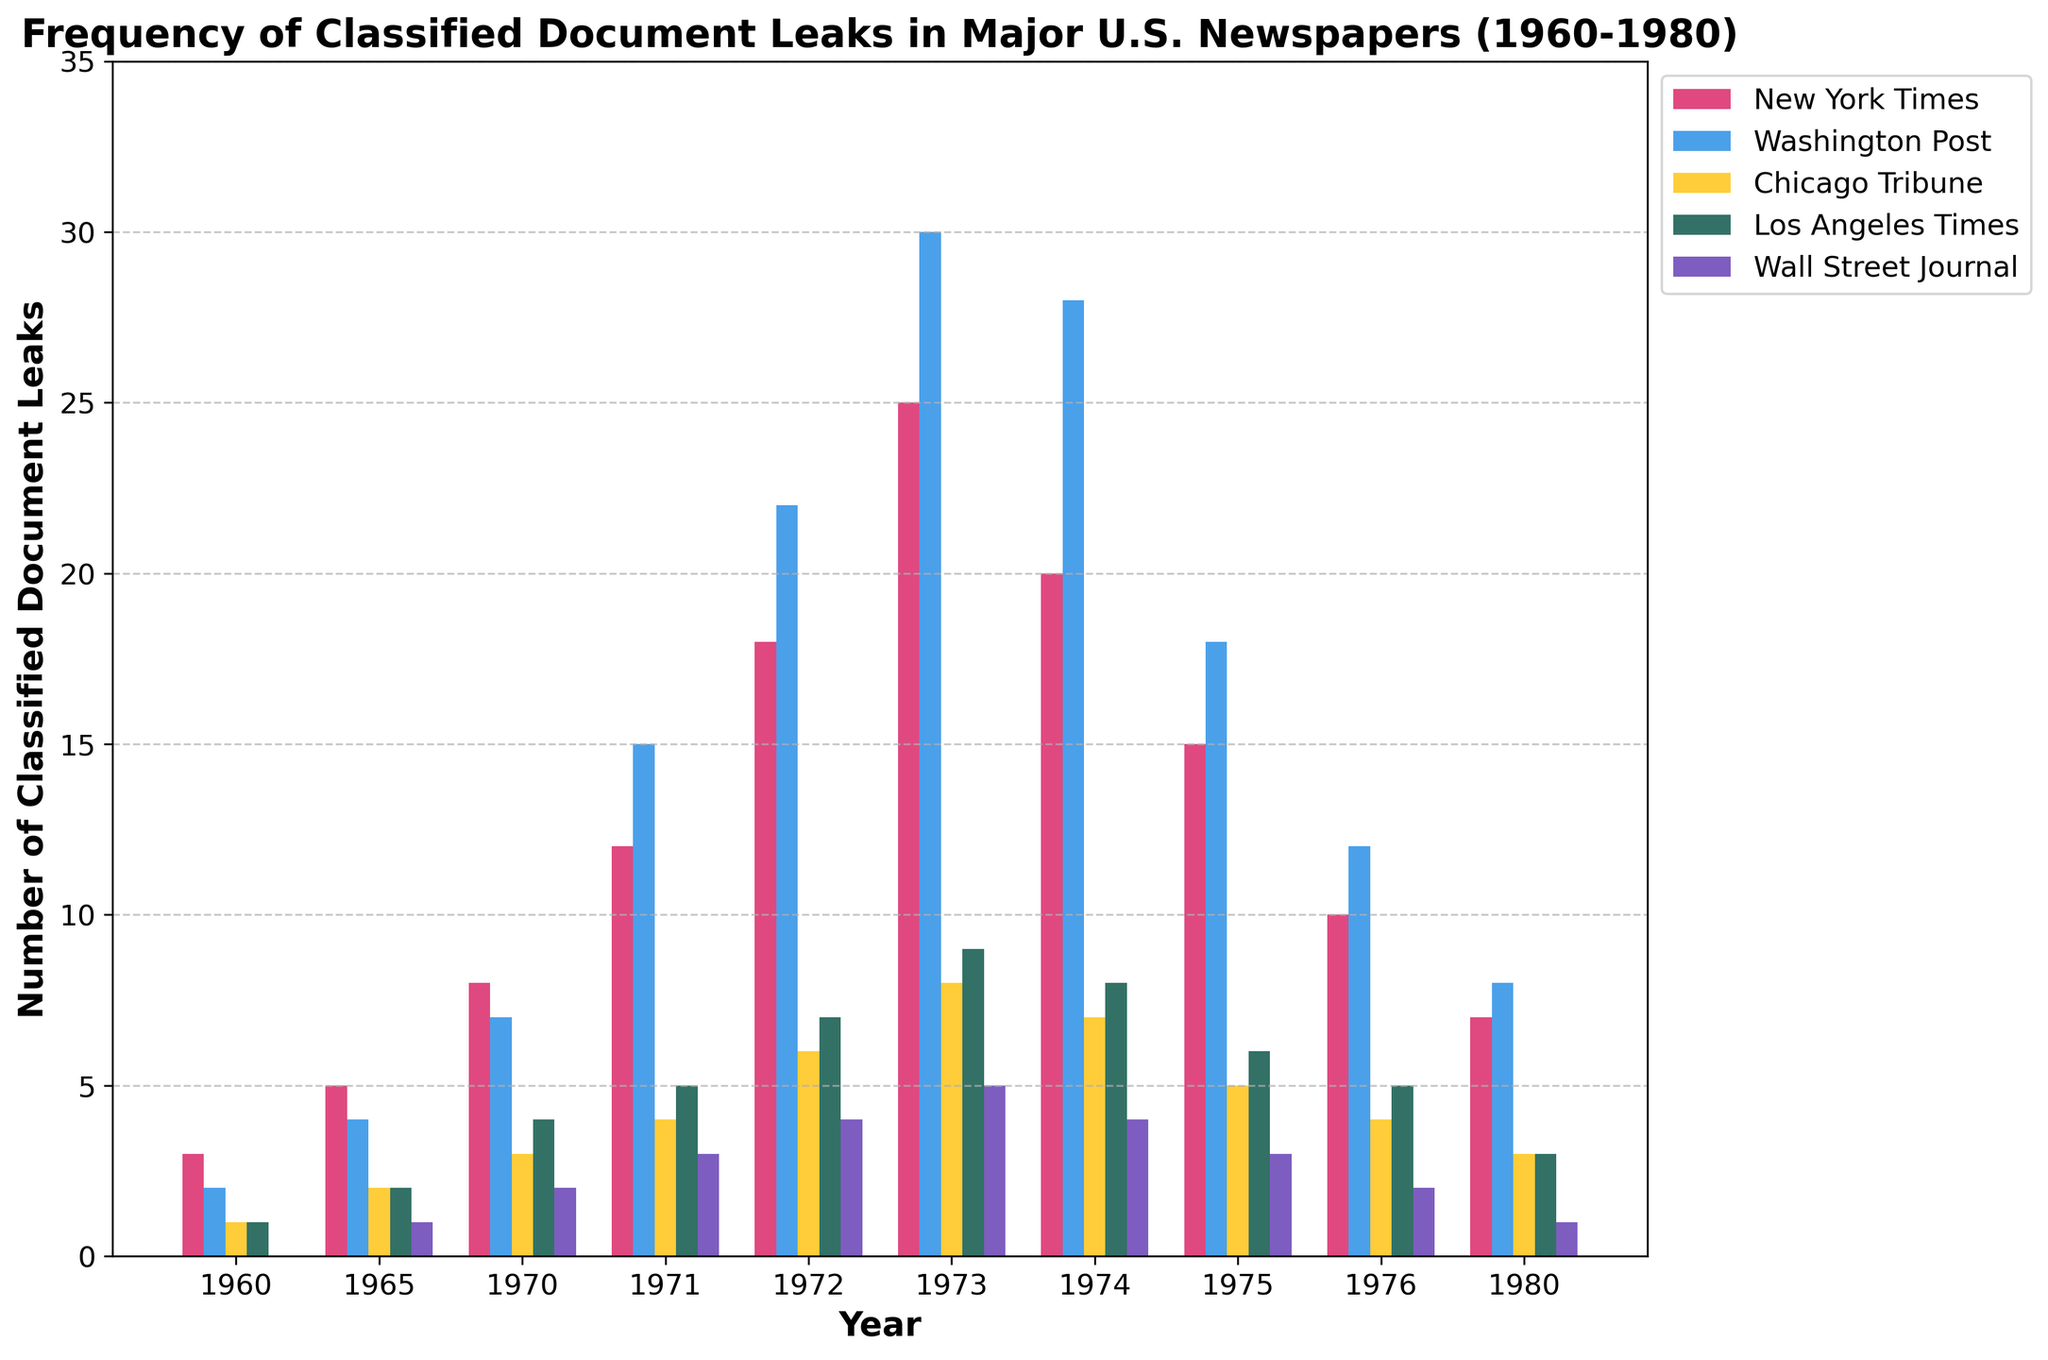Which newspaper had the highest number of classified document leaks in 1973? Looking at the bar corresponding to the year 1973, we see that the Washington Post's bar is the tallest among the newspapers.
Answer: Washington Post In which year did the New York Times have the highest number of classified document leaks? Comparing the heights of the red bars (New York Times) across all years, 1973 has the highest bar.
Answer: 1973 How does the number of classified document leaks in 1972 compare between the Chicago Tribune and the Wall Street Journal? Observing the bars for 1972, the Chicago Tribune had 6 leaks while the Wall Street Journal had 4 leaks.
Answer: Chicago Tribune had 2 more leaks than the Wall Street Journal What is the overall trend in the frequency of classified document leaks for the Los Angeles Times from 1960 to 1980? Observing the green bars representing the Los Angeles Times, there is an overall increase from 1960 to 1973 followed by a decrease until 1980.
Answer: Increase then Decrease Which year had the least number of classified document leaks for the Wall Street Journal, and how many were there? Observing the bars for the Wall Street Journal (purple) across the years, 1960 had zero leaks, the least.
Answer: 1960, 0 Compare the total classified document leaks of the New York Times and Washington Post in 1975? Adding the height of the red bar for New York Times (15) and blue bar for Washington Post (18) in 1975, Washington Post has more leaks.
Answer: Washington Post had 3 more leaks than New York Times What was the combined number of classified document leaks for all newspapers in 1970? Summing the heights of bars for all newspapers in 1970: 8 (NYT) + 7 (WP) + 3 (CT) + 4 (LAT) + 2 (WSJ) = 24
Answer: 24 Comparing 1974 and 1975, which year had more classified document leaks from the Los Angeles Times? Observing the green bars, 1974 had 8 leaks, while 1975 had 6 leaks.
Answer: 1974 What is the difference in the number of classified document leaks between the New York Times in 1973 and 1976? Finding the heights of red bars, in 1973 (25) and 1976 (10), the difference is 25 - 10 = 15.
Answer: 15 How did the frequency of leaks in the Washington Post change from 1971 to 1972? Observing the blue bars, in 1971 (15) and 1972 (22), the change is 22 - 15 = 7.
Answer: Increased by 7 